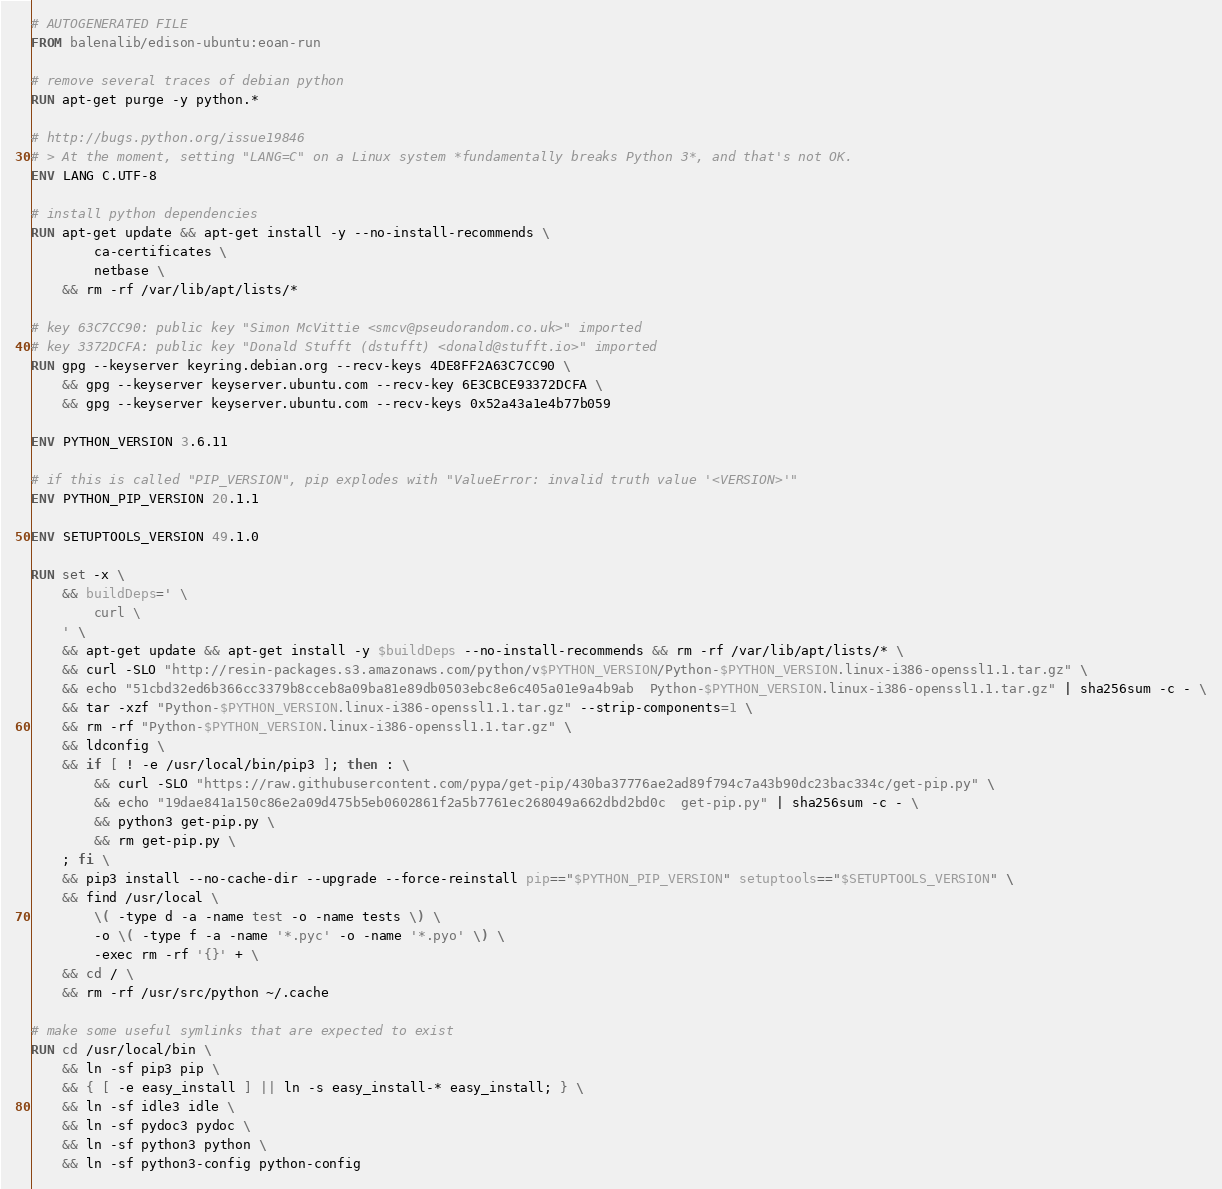Convert code to text. <code><loc_0><loc_0><loc_500><loc_500><_Dockerfile_># AUTOGENERATED FILE
FROM balenalib/edison-ubuntu:eoan-run

# remove several traces of debian python
RUN apt-get purge -y python.*

# http://bugs.python.org/issue19846
# > At the moment, setting "LANG=C" on a Linux system *fundamentally breaks Python 3*, and that's not OK.
ENV LANG C.UTF-8

# install python dependencies
RUN apt-get update && apt-get install -y --no-install-recommends \
		ca-certificates \
		netbase \
	&& rm -rf /var/lib/apt/lists/*

# key 63C7CC90: public key "Simon McVittie <smcv@pseudorandom.co.uk>" imported
# key 3372DCFA: public key "Donald Stufft (dstufft) <donald@stufft.io>" imported
RUN gpg --keyserver keyring.debian.org --recv-keys 4DE8FF2A63C7CC90 \
	&& gpg --keyserver keyserver.ubuntu.com --recv-key 6E3CBCE93372DCFA \
	&& gpg --keyserver keyserver.ubuntu.com --recv-keys 0x52a43a1e4b77b059

ENV PYTHON_VERSION 3.6.11

# if this is called "PIP_VERSION", pip explodes with "ValueError: invalid truth value '<VERSION>'"
ENV PYTHON_PIP_VERSION 20.1.1

ENV SETUPTOOLS_VERSION 49.1.0

RUN set -x \
	&& buildDeps=' \
		curl \
	' \
	&& apt-get update && apt-get install -y $buildDeps --no-install-recommends && rm -rf /var/lib/apt/lists/* \
	&& curl -SLO "http://resin-packages.s3.amazonaws.com/python/v$PYTHON_VERSION/Python-$PYTHON_VERSION.linux-i386-openssl1.1.tar.gz" \
	&& echo "51cbd32ed6b366cc3379b8cceb8a09ba81e89db0503ebc8e6c405a01e9a4b9ab  Python-$PYTHON_VERSION.linux-i386-openssl1.1.tar.gz" | sha256sum -c - \
	&& tar -xzf "Python-$PYTHON_VERSION.linux-i386-openssl1.1.tar.gz" --strip-components=1 \
	&& rm -rf "Python-$PYTHON_VERSION.linux-i386-openssl1.1.tar.gz" \
	&& ldconfig \
	&& if [ ! -e /usr/local/bin/pip3 ]; then : \
		&& curl -SLO "https://raw.githubusercontent.com/pypa/get-pip/430ba37776ae2ad89f794c7a43b90dc23bac334c/get-pip.py" \
		&& echo "19dae841a150c86e2a09d475b5eb0602861f2a5b7761ec268049a662dbd2bd0c  get-pip.py" | sha256sum -c - \
		&& python3 get-pip.py \
		&& rm get-pip.py \
	; fi \
	&& pip3 install --no-cache-dir --upgrade --force-reinstall pip=="$PYTHON_PIP_VERSION" setuptools=="$SETUPTOOLS_VERSION" \
	&& find /usr/local \
		\( -type d -a -name test -o -name tests \) \
		-o \( -type f -a -name '*.pyc' -o -name '*.pyo' \) \
		-exec rm -rf '{}' + \
	&& cd / \
	&& rm -rf /usr/src/python ~/.cache

# make some useful symlinks that are expected to exist
RUN cd /usr/local/bin \
	&& ln -sf pip3 pip \
	&& { [ -e easy_install ] || ln -s easy_install-* easy_install; } \
	&& ln -sf idle3 idle \
	&& ln -sf pydoc3 pydoc \
	&& ln -sf python3 python \
	&& ln -sf python3-config python-config
</code> 